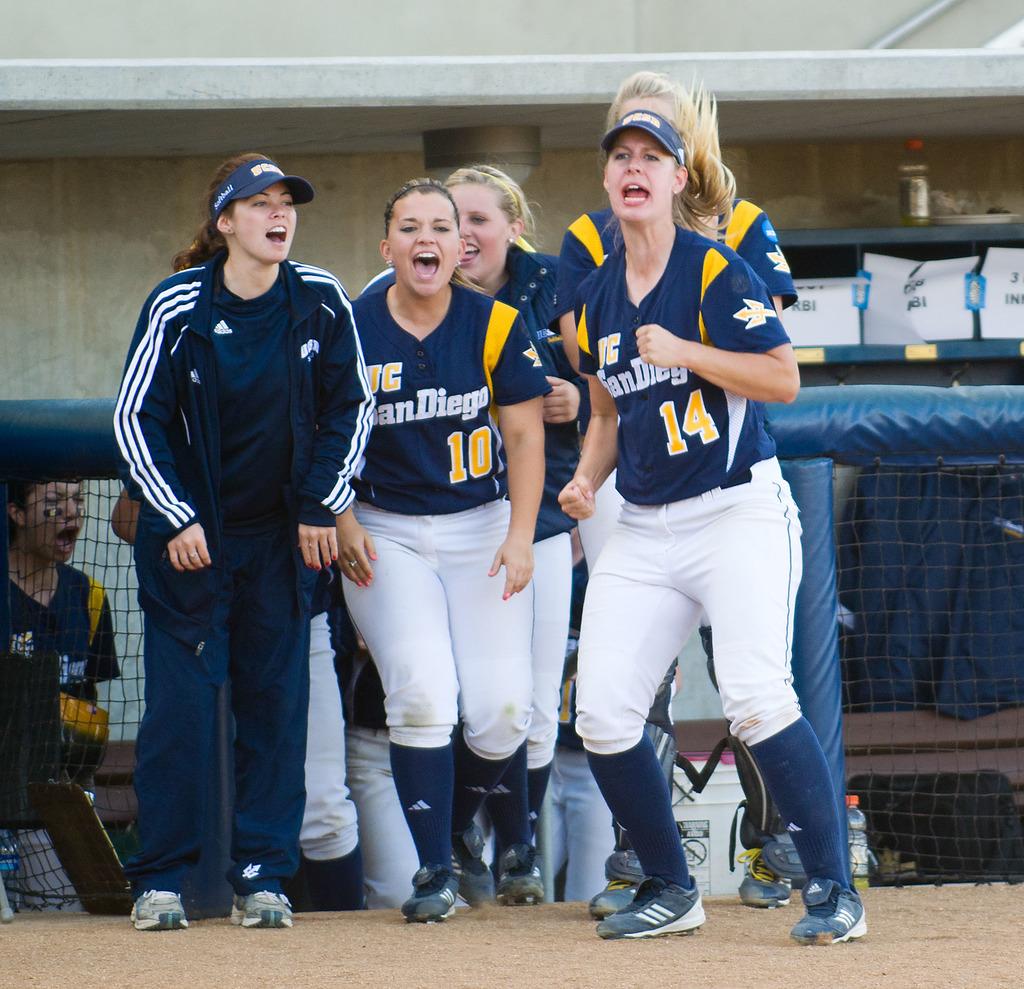Who number is the rightmost player?
Your answer should be very brief. 14. 